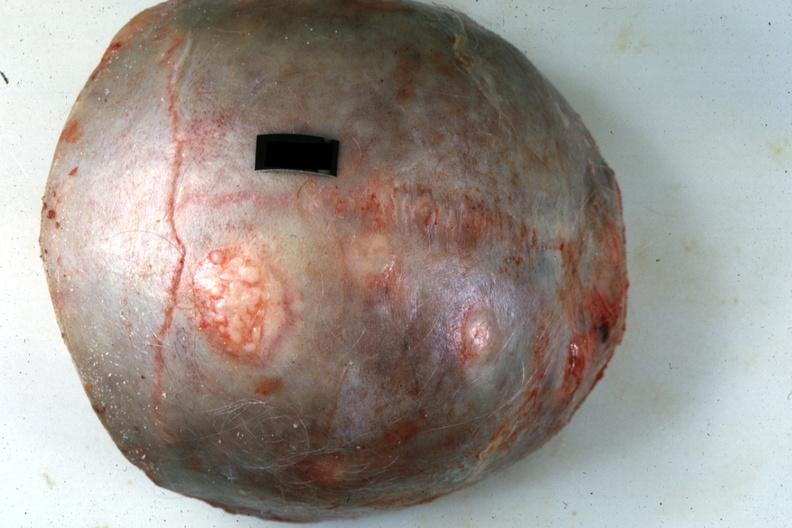how does this image show skull cap?
Answer the question using a single word or phrase. With obvious metastatic lesions primary in pancreas 